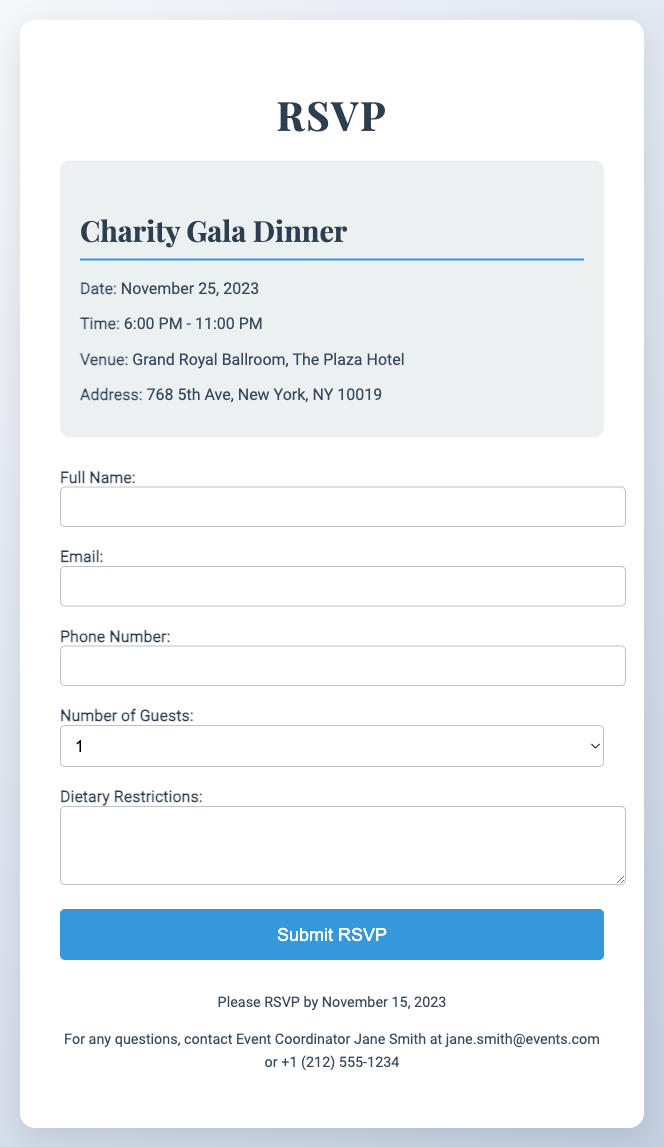What is the date of the event? The date of the event is prominently stated in the document.
Answer: November 25, 2023 What time does the Charity Gala Dinner start? The time is clearly indicated in the event details section of the document.
Answer: 6:00 PM Where is the venue located? The venue's name and location are provided in the same section.
Answer: Grand Royal Ballroom, The Plaza Hotel How many guests can be selected in the RSVP? The RSVP form specifies the options available for guests.
Answer: 4 Who should be contacted for questions? The footer of the document states who to contact for any inquiries.
Answer: Jane Smith How should dietary restrictions be communicated? The document provides a specific section for dietary preferences in the RSVP form.
Answer: Text area in the form What is the RSVP deadline? The RSVP deadline is mentioned in the footer section of the document.
Answer: November 15, 2023 What is the main theme of the event? The title of the event indicates its main purpose.
Answer: Charity Gala Dinner 